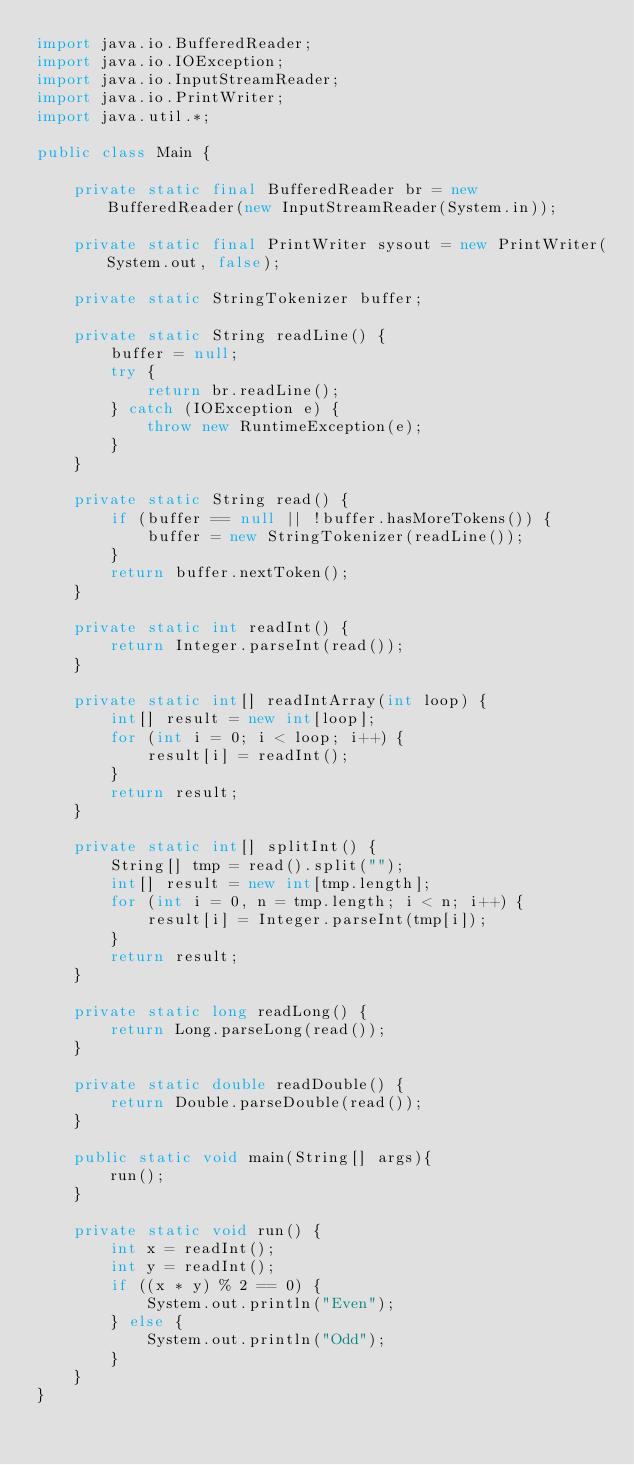<code> <loc_0><loc_0><loc_500><loc_500><_Java_>import java.io.BufferedReader;
import java.io.IOException;
import java.io.InputStreamReader;
import java.io.PrintWriter;
import java.util.*;

public class Main {

    private static final BufferedReader br = new BufferedReader(new InputStreamReader(System.in));

    private static final PrintWriter sysout = new PrintWriter(System.out, false);

    private static StringTokenizer buffer;

    private static String readLine() {
        buffer = null;
        try {
            return br.readLine();
        } catch (IOException e) {
            throw new RuntimeException(e);
        }
    }

    private static String read() {
        if (buffer == null || !buffer.hasMoreTokens()) {
            buffer = new StringTokenizer(readLine());
        }
        return buffer.nextToken();
    }

    private static int readInt() {
        return Integer.parseInt(read());
    }

    private static int[] readIntArray(int loop) {
        int[] result = new int[loop];
        for (int i = 0; i < loop; i++) {
            result[i] = readInt();
        }
        return result;
    }

    private static int[] splitInt() {
        String[] tmp = read().split("");
        int[] result = new int[tmp.length];
        for (int i = 0, n = tmp.length; i < n; i++) {
            result[i] = Integer.parseInt(tmp[i]);
        }
        return result;
    }

    private static long readLong() {
        return Long.parseLong(read());
    }

    private static double readDouble() {
        return Double.parseDouble(read());
    }

    public static void main(String[] args){
        run();
    }

    private static void run() {
        int x = readInt();
        int y = readInt();
        if ((x * y) % 2 == 0) {
            System.out.println("Even");
        } else {
            System.out.println("Odd");
        }
    }
}
</code> 